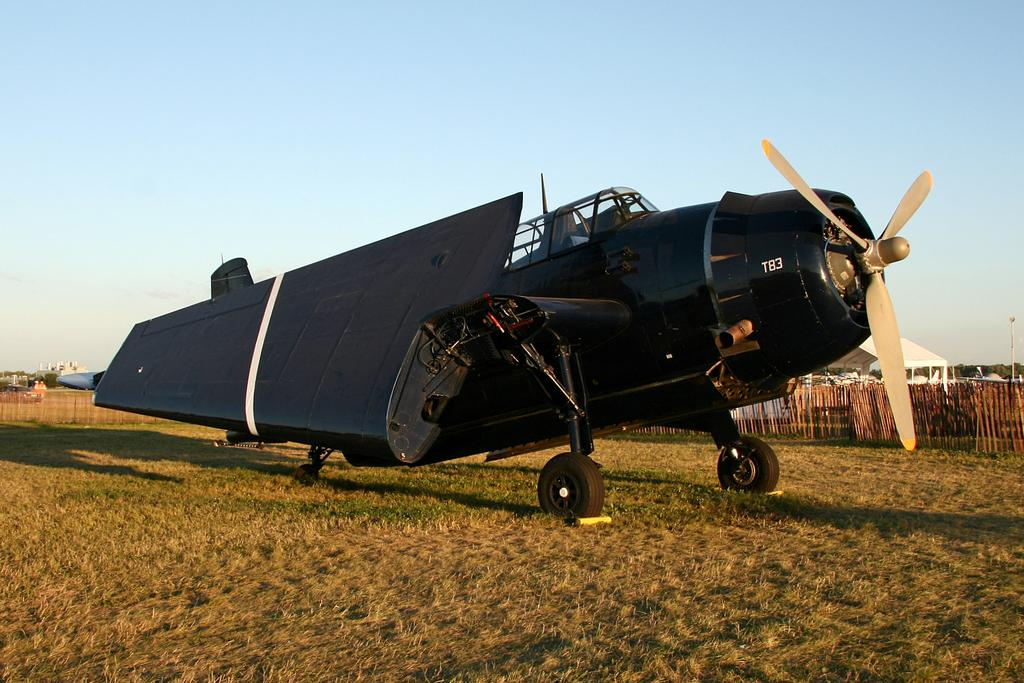<image>
Provide a brief description of the given image. Old fashion T83 airplane on display in a grassy field. 